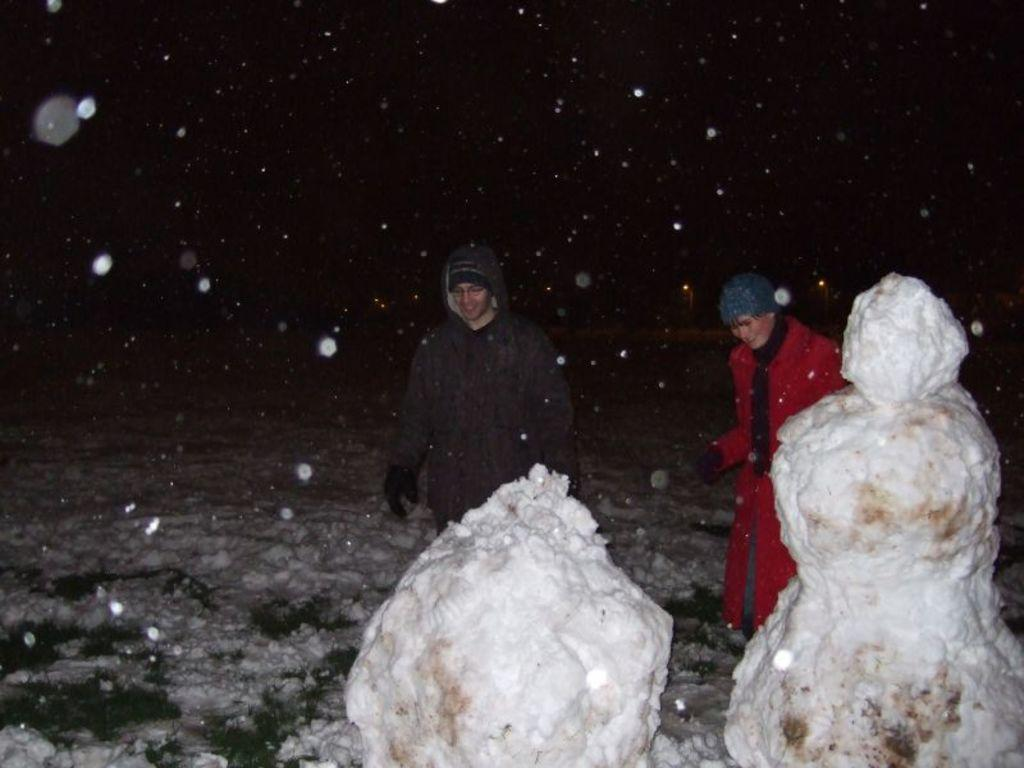What type of dolls are in the image? There are snow dolls in the image. Can you describe the people in the background of the image? There are two persons standing in the background of the image. What is the color of the sky in the image? The sky is black in color. What degree do the girls in the image have? There is no mention of girls or degrees in the image, so this information cannot be determined. 